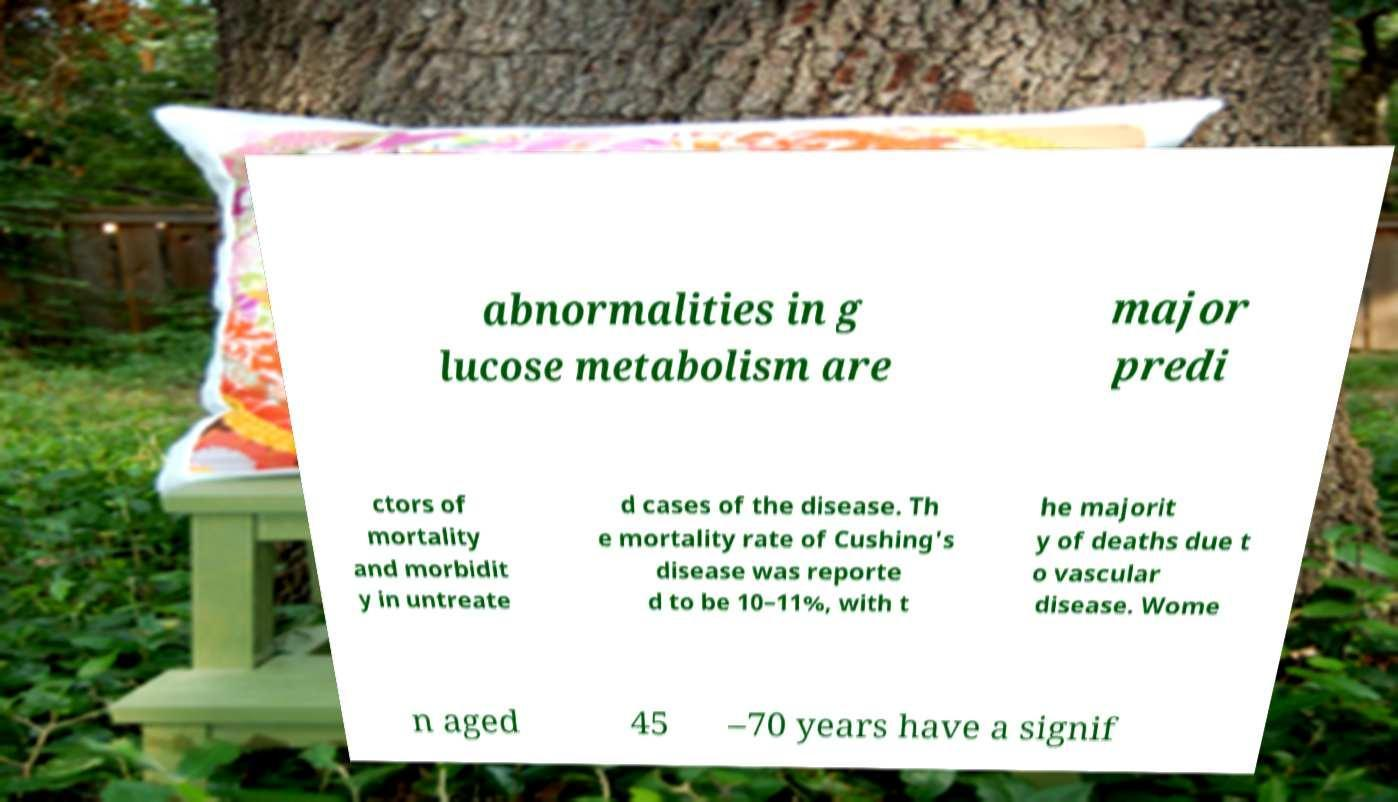Could you assist in decoding the text presented in this image and type it out clearly? abnormalities in g lucose metabolism are major predi ctors of mortality and morbidit y in untreate d cases of the disease. Th e mortality rate of Cushing's disease was reporte d to be 10–11%, with t he majorit y of deaths due t o vascular disease. Wome n aged 45 –70 years have a signif 